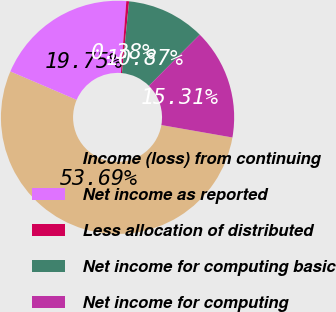Convert chart. <chart><loc_0><loc_0><loc_500><loc_500><pie_chart><fcel>Income (loss) from continuing<fcel>Net income as reported<fcel>Less allocation of distributed<fcel>Net income for computing basic<fcel>Net income for computing<nl><fcel>53.69%<fcel>19.75%<fcel>0.38%<fcel>10.87%<fcel>15.31%<nl></chart> 